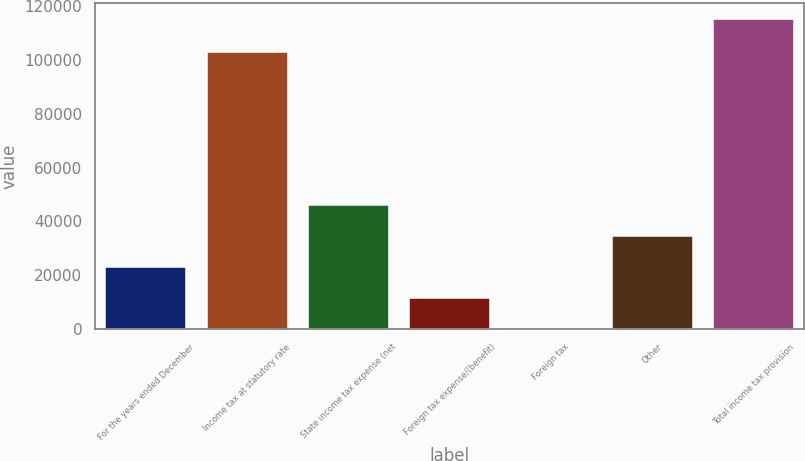Convert chart. <chart><loc_0><loc_0><loc_500><loc_500><bar_chart><fcel>For the years ended December<fcel>Income tax at statutory rate<fcel>State income tax expense (net<fcel>Foreign tax expense/(benefit)<fcel>Foreign tax<fcel>Other<fcel>Total income tax provision<nl><fcel>23252.4<fcel>103075<fcel>46283.8<fcel>11736.7<fcel>221<fcel>34768.1<fcel>115378<nl></chart> 